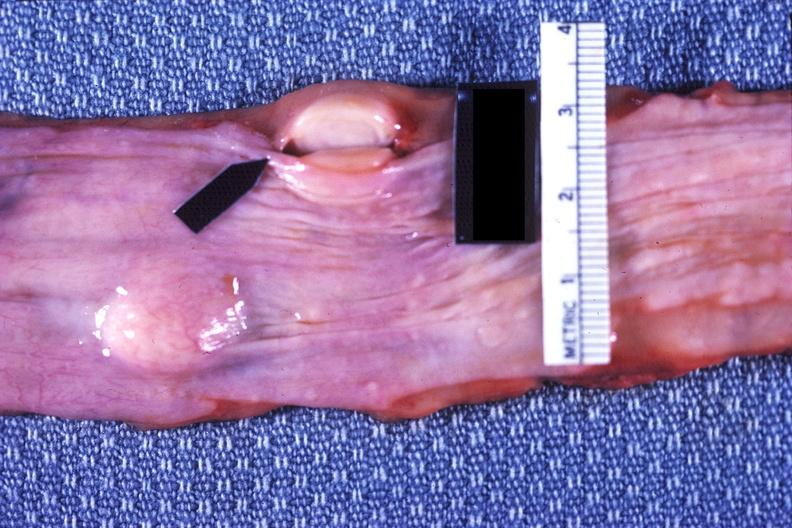s anomalous origin present?
Answer the question using a single word or phrase. No 